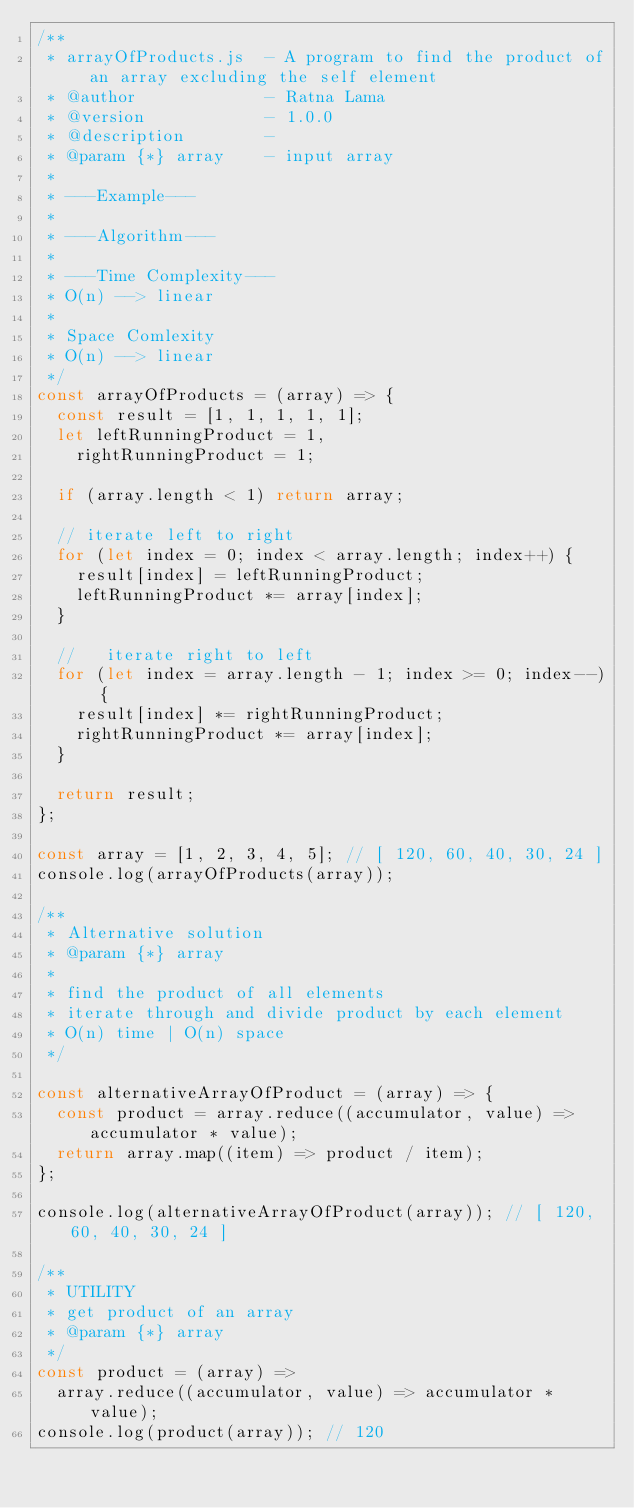<code> <loc_0><loc_0><loc_500><loc_500><_JavaScript_>/**
 * arrayOfProducts.js  - A program to find the product of an array excluding the self element
 * @author             - Ratna Lama
 * @version            - 1.0.0
 * @description        -
 * @param {*} array    - input array
 *
 * ---Example---
 *
 * ---Algorithm---
 *
 * ---Time Complexity---
 * O(n) --> linear
 *
 * Space Comlexity
 * O(n) --> linear
 */
const arrayOfProducts = (array) => {
  const result = [1, 1, 1, 1, 1];
  let leftRunningProduct = 1,
    rightRunningProduct = 1;

  if (array.length < 1) return array;

  // iterate left to right
  for (let index = 0; index < array.length; index++) {
    result[index] = leftRunningProduct;
    leftRunningProduct *= array[index];
  }

  //   iterate right to left
  for (let index = array.length - 1; index >= 0; index--) {
    result[index] *= rightRunningProduct;
    rightRunningProduct *= array[index];
  }

  return result;
};

const array = [1, 2, 3, 4, 5]; // [ 120, 60, 40, 30, 24 ]
console.log(arrayOfProducts(array));

/**
 * Alternative solution
 * @param {*} array
 *
 * find the product of all elements
 * iterate through and divide product by each element
 * O(n) time | O(n) space
 */

const alternativeArrayOfProduct = (array) => {
  const product = array.reduce((accumulator, value) => accumulator * value);
  return array.map((item) => product / item);
};

console.log(alternativeArrayOfProduct(array)); // [ 120, 60, 40, 30, 24 ]

/**
 * UTILITY
 * get product of an array
 * @param {*} array
 */
const product = (array) =>
  array.reduce((accumulator, value) => accumulator * value);
console.log(product(array)); // 120
</code> 